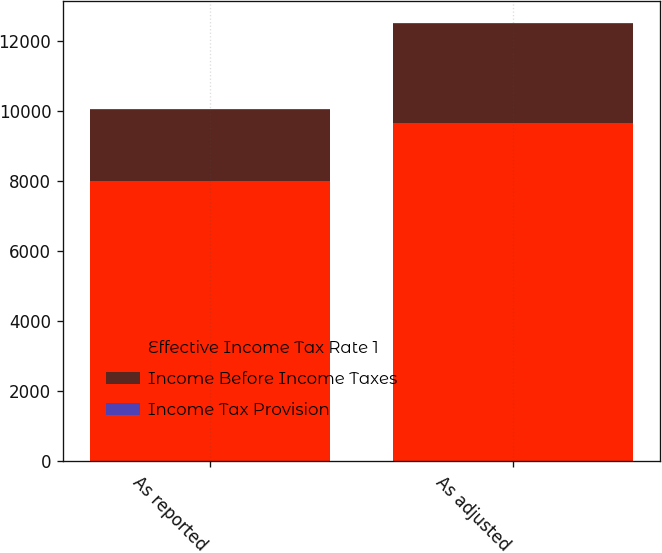Convert chart to OTSL. <chart><loc_0><loc_0><loc_500><loc_500><stacked_bar_chart><ecel><fcel>As reported<fcel>As adjusted<nl><fcel>Effective Income Tax Rate 1<fcel>8012<fcel>9677<nl><fcel>Income Before Income Taxes<fcel>2021<fcel>2815<nl><fcel>Income Tax Provision<fcel>25.2<fcel>29.1<nl></chart> 